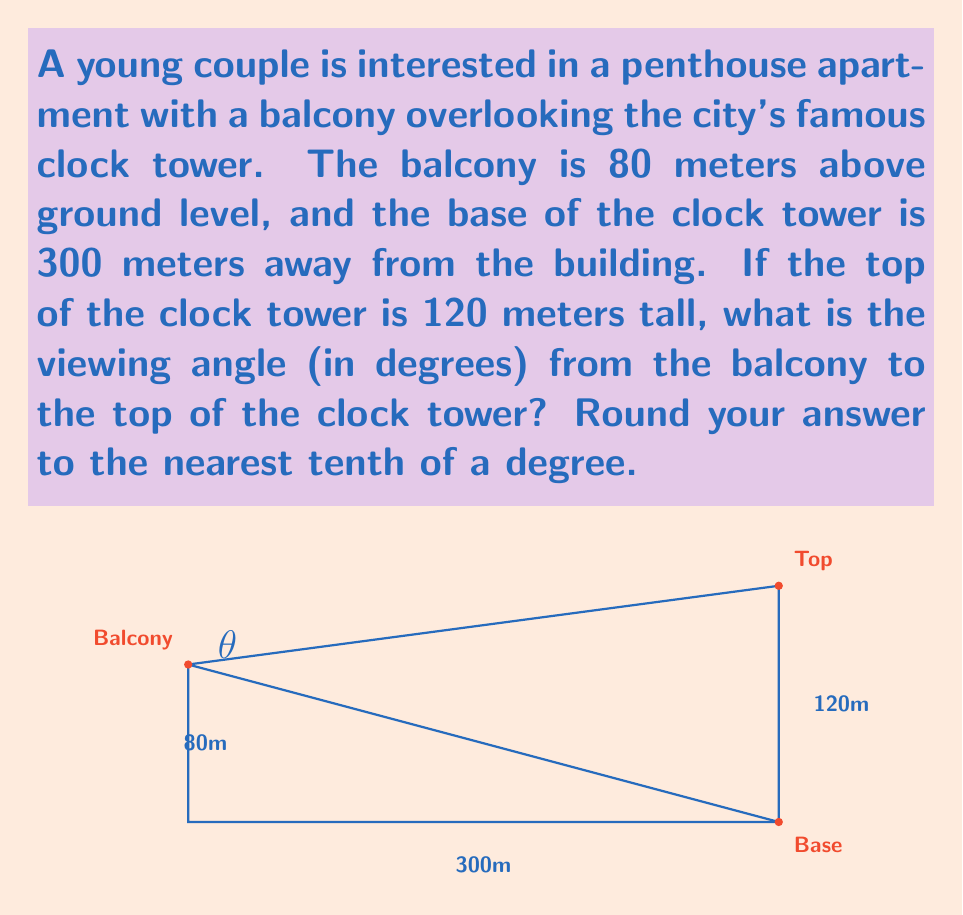What is the answer to this math problem? To solve this problem, we can use trigonometry, specifically the tangent function. Let's break it down step-by-step:

1) First, we need to identify the right triangle formed by the balcony, the base of the tower, and the top of the tower.

2) The vertical distance from the balcony to the top of the tower is the sum of the balcony height and the tower height:
   $80 + 120 = 200$ meters

3) The horizontal distance from the balcony to the base of the tower is given as 300 meters.

4) Now we have a right triangle where:
   - The adjacent side (horizontal distance) is 300 meters
   - The opposite side (vertical distance to top) is 200 meters
   - The angle we're looking for is the one formed at the balcony

5) We can use the tangent function to find this angle:

   $$\tan(\theta) = \frac{\text{opposite}}{\text{adjacent}} = \frac{200}{300}$$

6) To find $\theta$, we need to use the inverse tangent (arctan or $\tan^{-1}$):

   $$\theta = \tan^{-1}\left(\frac{200}{300}\right)$$

7) Using a calculator or computer:

   $$\theta \approx 33.69^\circ$$

8) Rounding to the nearest tenth of a degree:

   $$\theta \approx 33.7^\circ$$

This angle represents the upward tilt needed to view the top of the clock tower from the balcony, which can be a selling point for the real estate agent when discussing the property's views with the newlywed couple.
Answer: $33.7^\circ$ 